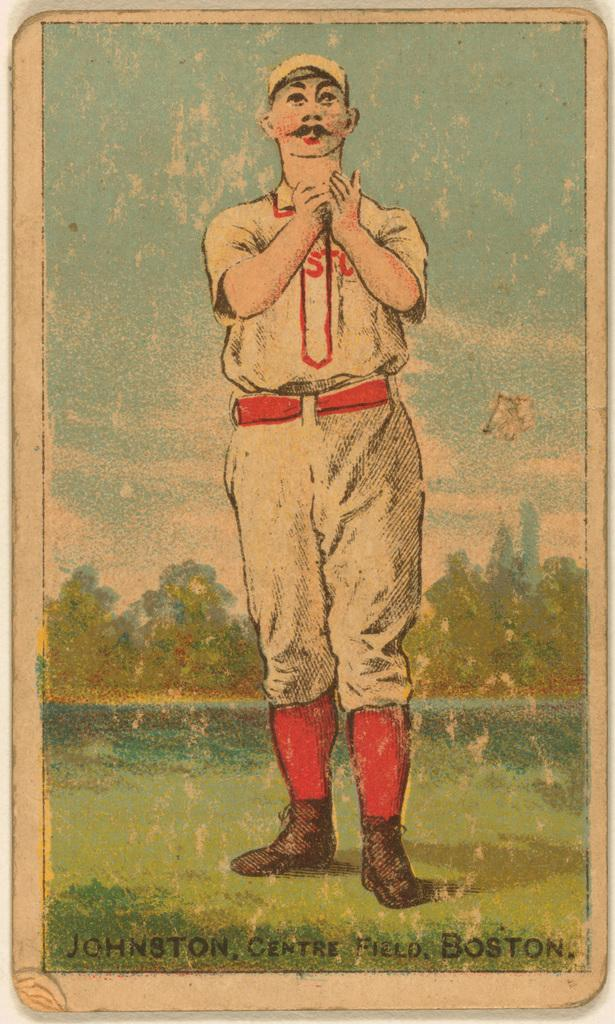What is the main subject of the image? There is a depiction of a person in the image. What else can be seen in the image besides the person? There is writing in the image. What type of tin vessel is being used by the person in the image? There is no tin vessel present in the image; it only depicts a person and writing. 